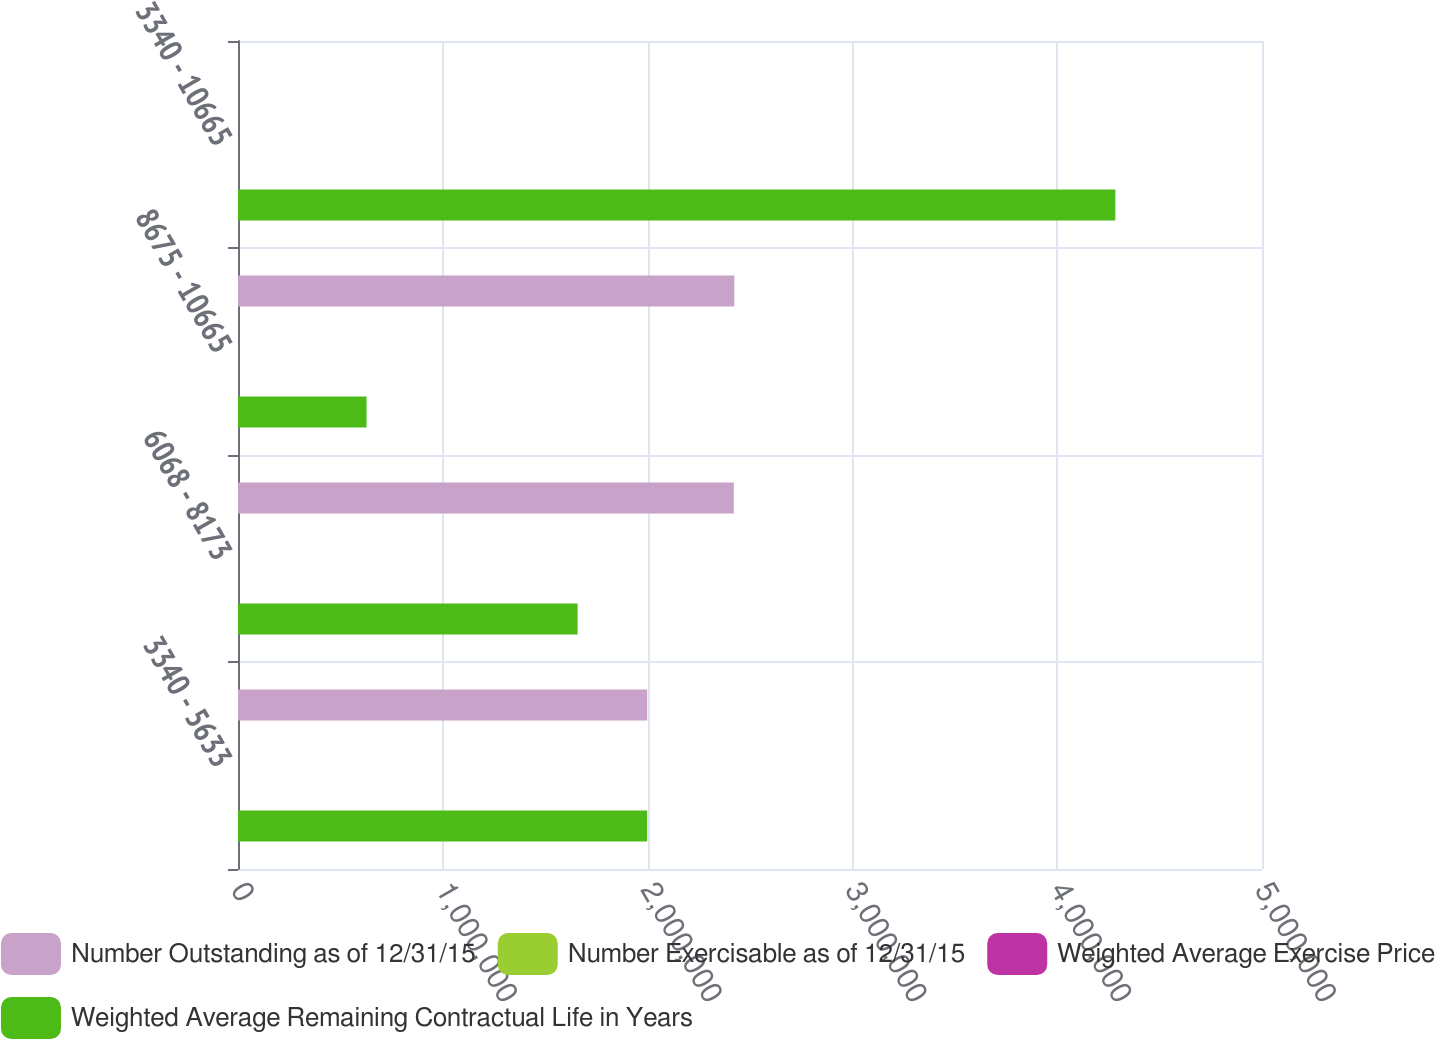<chart> <loc_0><loc_0><loc_500><loc_500><stacked_bar_chart><ecel><fcel>3340 - 5633<fcel>6068 - 8173<fcel>8675 - 10665<fcel>3340 - 10665<nl><fcel>Number Outstanding as of 12/31/15<fcel>1.99806e+06<fcel>2.42094e+06<fcel>2.42356e+06<fcel>105.09<nl><fcel>Number Exercisable as of 12/31/15<fcel>3.2<fcel>5.8<fcel>7.9<fcel>5.8<nl><fcel>Weighted Average Exercise Price<fcel>44.52<fcel>71.38<fcel>105.09<fcel>75.48<nl><fcel>Weighted Average Remaining Contractual Life in Years<fcel>1.99806e+06<fcel>1.6582e+06<fcel>627759<fcel>4.28401e+06<nl></chart> 